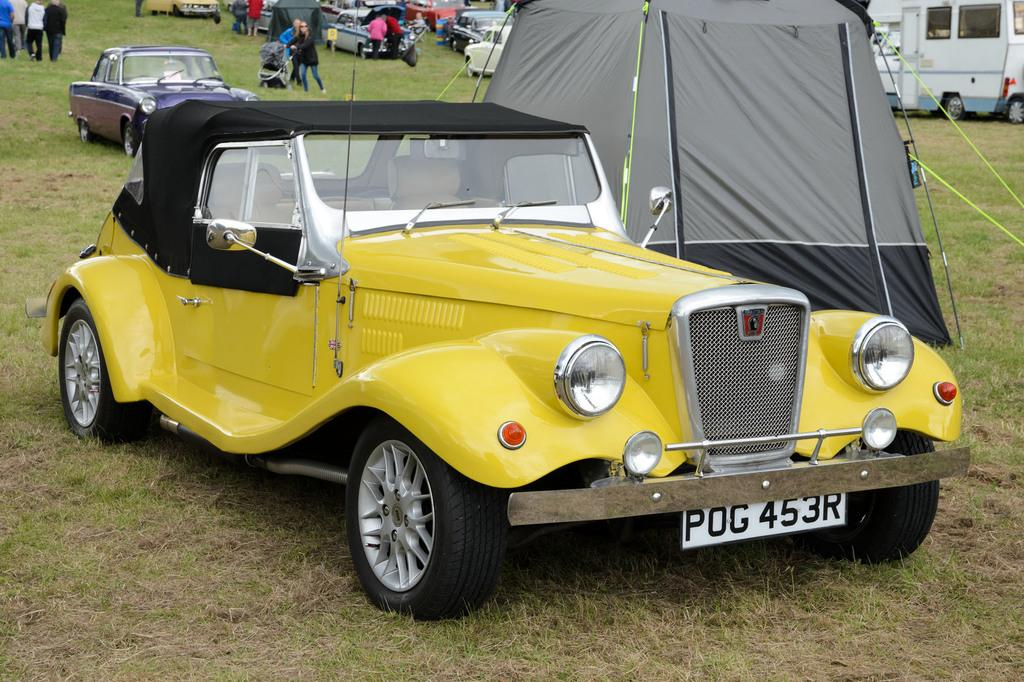What type of vehicles are present in the image? There are cars in the image. What type of temporary shelters can be seen in the image? There are tents in the image. Where are the cars and tents located? The cars and tents are on a land. Can you describe the people visible in the background of the image? There are people visible in the background of the image, but their specific characteristics are not discernible from the provided facts. What type of plantation is visible in the image? There is no plantation present in the image. What is the relation between the cars and the tents in the image? The provided facts do not give any information about the relationship between the cars and the tents. 